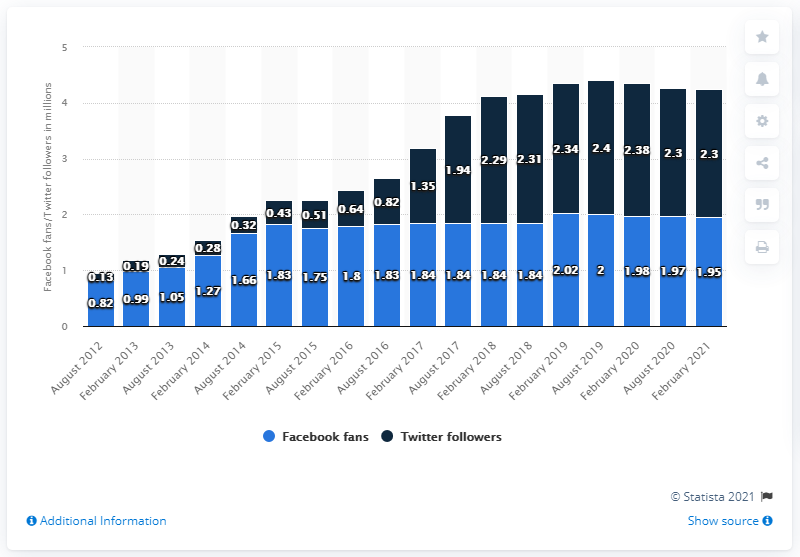Highlight a few significant elements in this photo. As of February 2021, the Atlanta Falcons football team had 1.95 million Facebook followers. 